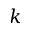Convert formula to latex. <formula><loc_0><loc_0><loc_500><loc_500>k</formula> 